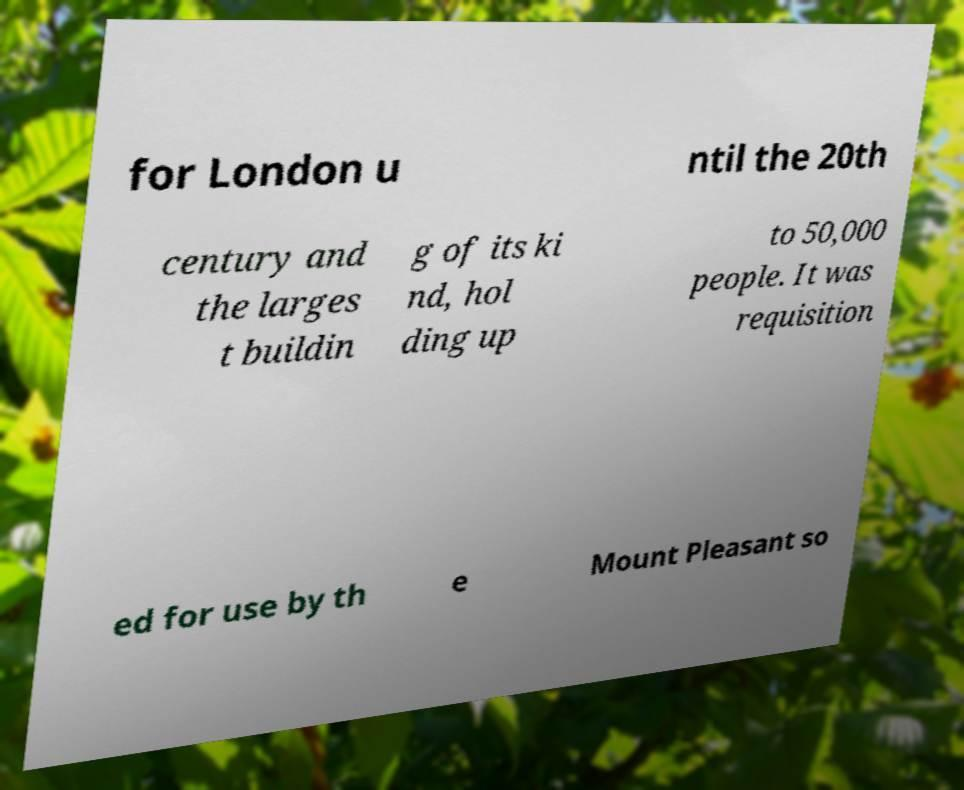Could you extract and type out the text from this image? for London u ntil the 20th century and the larges t buildin g of its ki nd, hol ding up to 50,000 people. It was requisition ed for use by th e Mount Pleasant so 